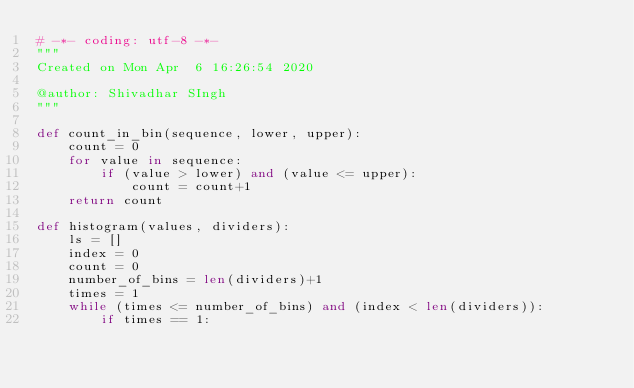Convert code to text. <code><loc_0><loc_0><loc_500><loc_500><_Python_># -*- coding: utf-8 -*-
"""
Created on Mon Apr  6 16:26:54 2020

@author: Shivadhar SIngh
"""

def count_in_bin(sequence, lower, upper):
    count = 0
    for value in sequence:
        if (value > lower) and (value <= upper):
            count = count+1
    return count

def histogram(values, dividers):
    ls = []
    index = 0
    count = 0
    number_of_bins = len(dividers)+1
    times = 1
    while (times <= number_of_bins) and (index < len(dividers)):
        if times == 1:</code> 